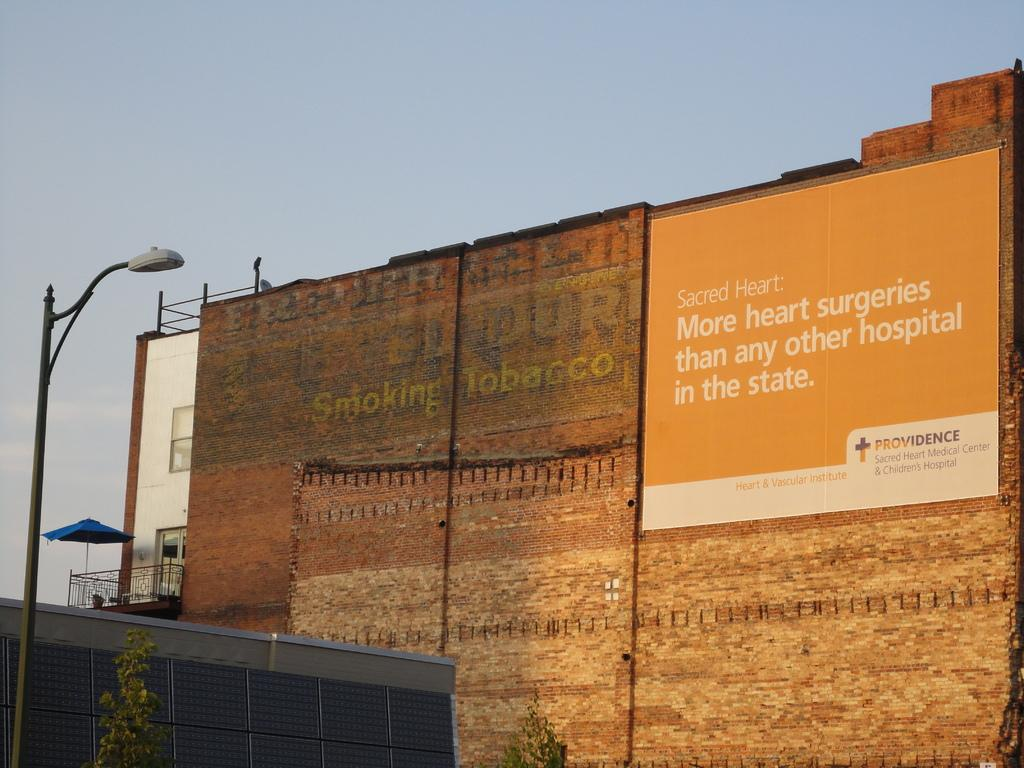What is attached to the pole in the image? There is a light attached to the pole in the image. What type of vegetation is present in the image? There are trees in the image. What is on the wall in the image? There is a hoarding on the wall in the image. What type of structures can be seen in the image? There are buildings visible in the image. What part of the natural environment is visible in the image? The sky is visible in the image. Can you tell me what type of toy is hanging from the light in the image? There is no toy hanging from the light in the image; it is a pole with a light attached to it. What color is the patch on the wall in the image? There is no patch on the wall in the image; it has a hoarding instead. 